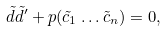<formula> <loc_0><loc_0><loc_500><loc_500>\tilde { d } \tilde { d } ^ { \prime } + p ( \tilde { c } _ { 1 } \dots \tilde { c } _ { n } ) = 0 ,</formula> 